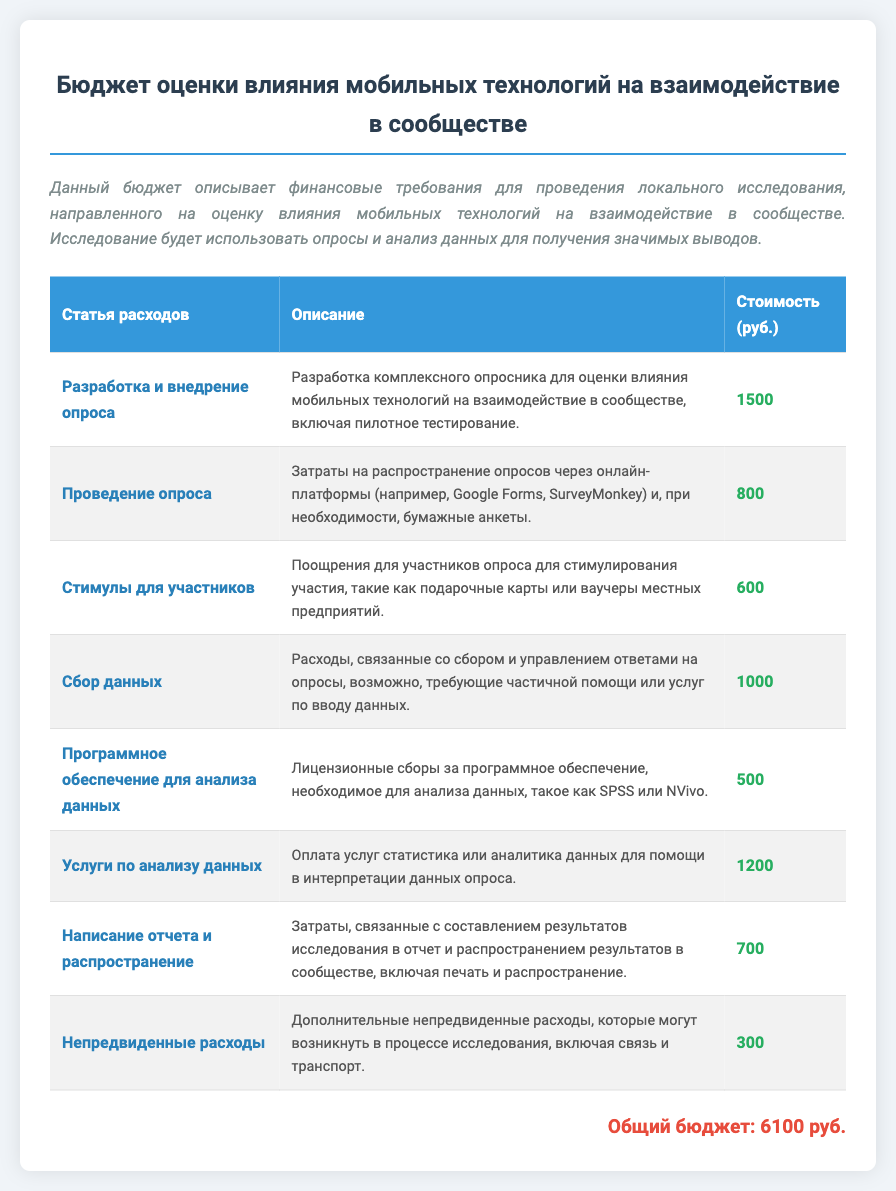Какова общая сумма бюджета? Общая сумма бюджета указана в документе как сумма всех статей расходов.
Answer: 6100 руб Сколько стоит проведение опроса? Стоимость проведения опроса указана в таблице среди статей расходов.
Answer: 800 руб Какую сумму выделено на стимулы для участников? Сумма для стимулов указана в соответствующей строке таблицы.
Answer: 600 руб Каково описание статьи расходов на программное обеспечение для анализа данных? Описание данной статьи расходов приведено в таблице, в соответствующей колонке.
Answer: Лицензионные сборы за программное обеспечение, необходимое для анализа данных, такое как SPSS или NVivo Кто помогает в интерпретации данных опроса? В документе указано, что услуги по анализу данных включает помощь статистика или аналитика данных.
Answer: Статистик или аналитик данных Сколько стоит написание отчета и его распространение? Стоимость указана в таблице под соответствующей статьей расходов.
Answer: 700 руб Что включают непредвиденные расходы? Описание непредвиденных расходов находится в таблице, где указано, на что могут быть потрачены дополнительные средства.
Answer: Связь и транспорт Какова стоимость услуги по анализу данных? Стоимость данной услуги четко указана в документе.
Answer: 1200 руб 